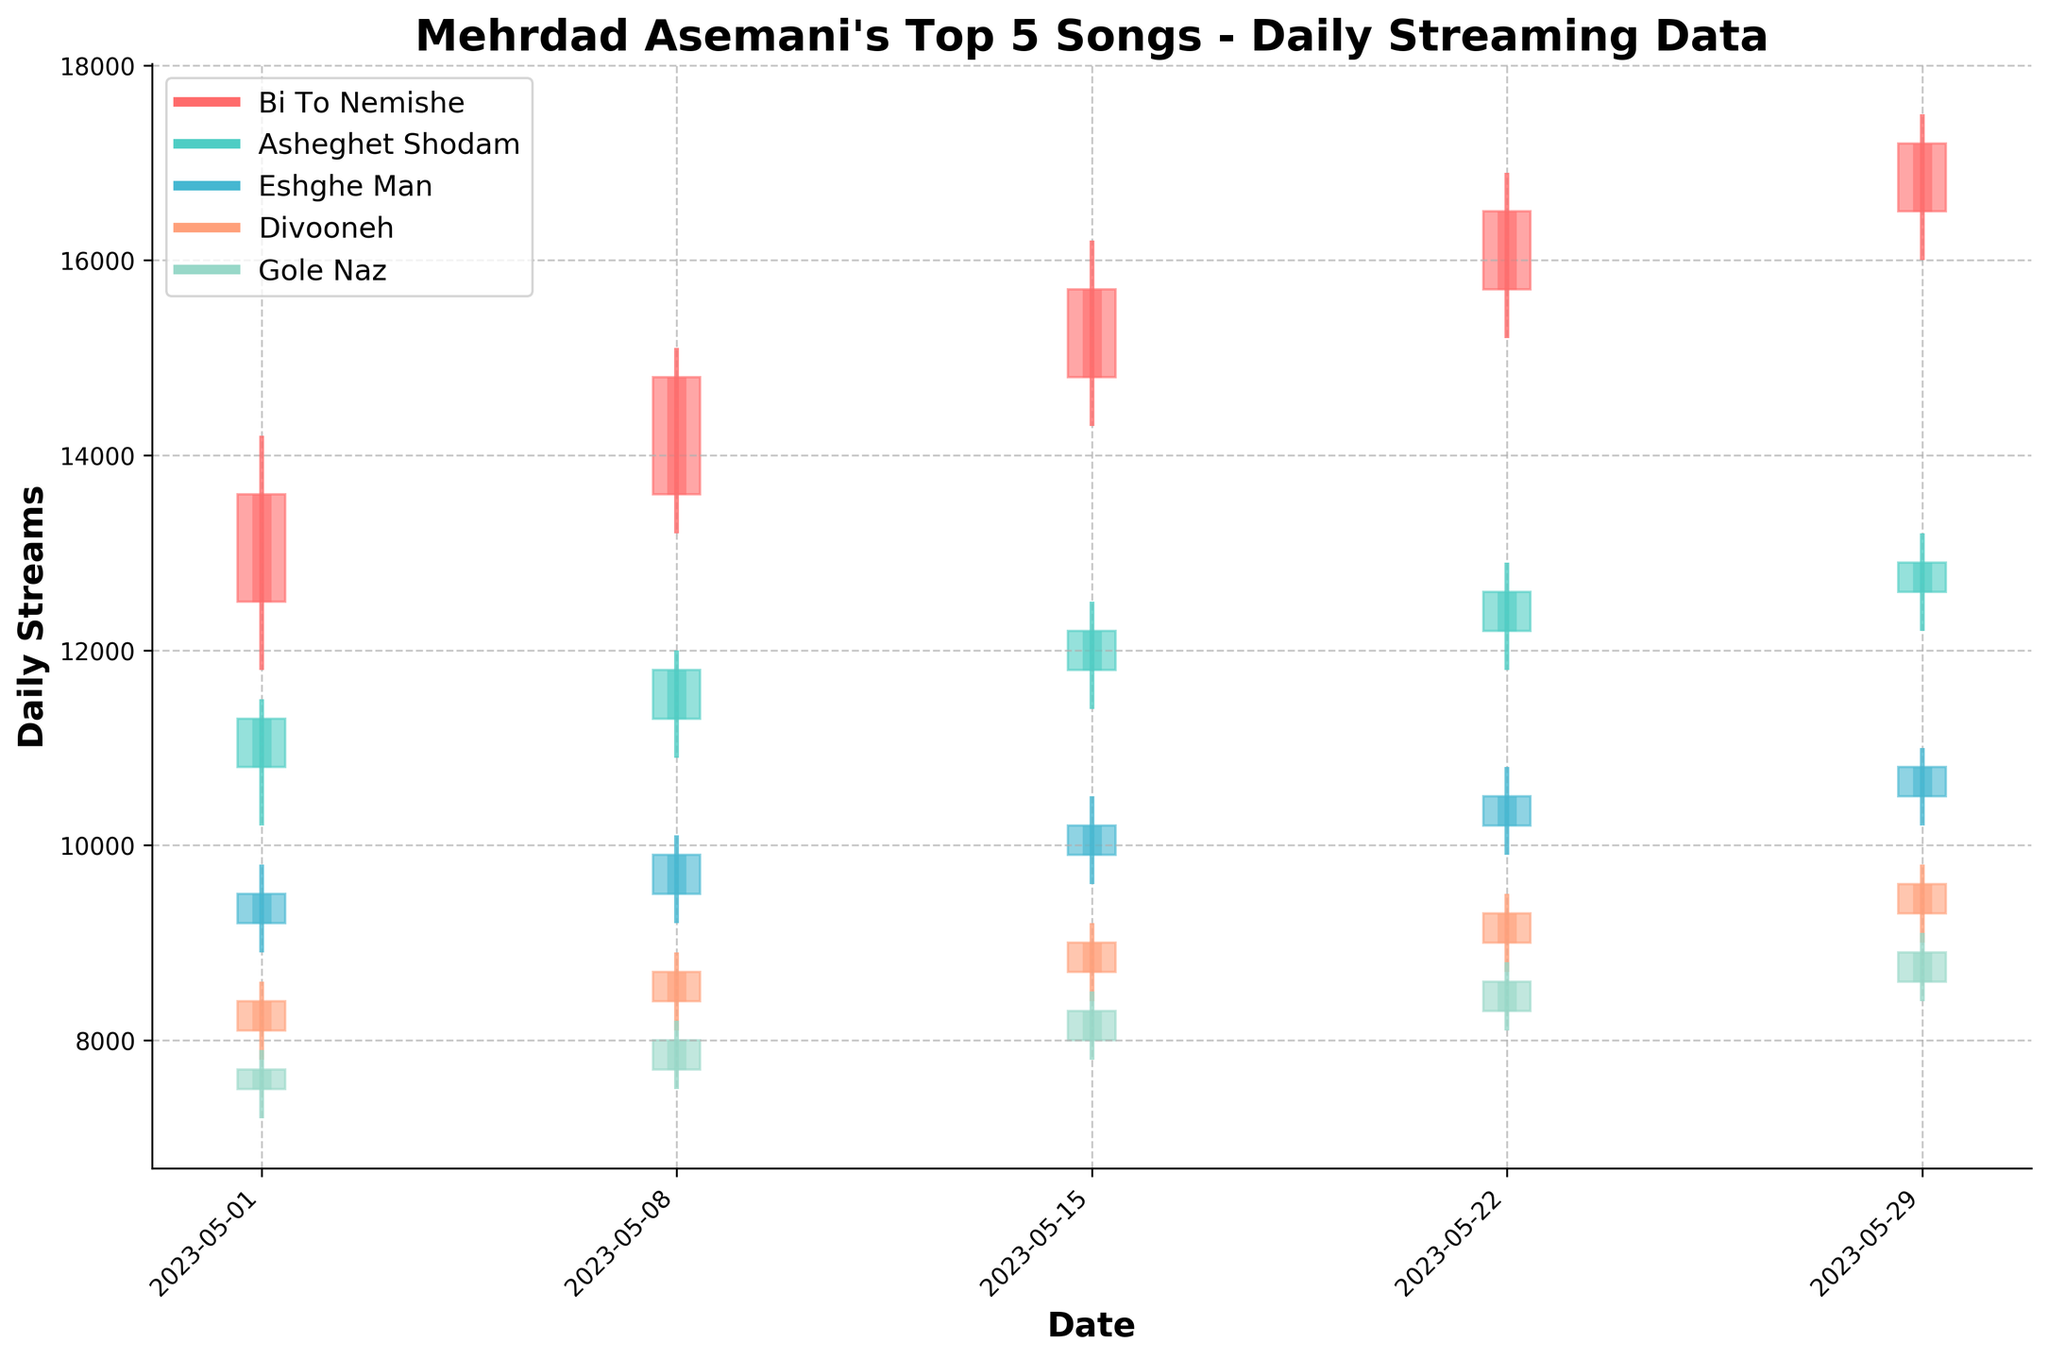What's the title of the chart? The title is usually found at the top of the chart and summarizes the main idea of the visual representation. Here, it states "Mehrdad Asemani's Top 5 Songs - Daily Streaming Data".
Answer: Mehrdad Asemani's Top 5 Songs - Daily Streaming Data What are the date ranges covered in the chart? The dates are usually presented along the x-axis. In this chart, the dates range from 2023-05-01 to 2023-05-29.
Answer: 2023-05-01 to 2023-05-29 Which color represents the song "Divooneh"? Different colors are used to distinguish the songs. By checking the legend, we see that "Divooneh" is represented in a blue shade.
Answer: Blue Which song had the highest closing value on May 29, 2023? To answer this, we locate the May 29, 2023 on the x-axis and compare each song’s closing values. "Bi To Nemishe" had the highest closing value at 17200 streams.
Answer: Bi To Nemishe On which date did the song "Eshghe Man" have the lowest closing value, and what was it? Looking at "Eshghe Man" data points along the x-axis, we find that the closing value was lowest on May 01, 2023, at 9500 streams.
Answer: May 01, 2023, at 9500 streams How did the streaming numbers for "Gole Naz" change from May 01 to May 08, 2023? Compare the opening and closing values for these dates: May 01 (Open: 7500, Close: 7700) and May 08 (Open: 7700, Close: 8000). It shows an increase in both opening and closing values.
Answer: Increased What was the overall trend for the song "Asheghet Shodam" over the month? Observing "Asheghet Shodam" across the x-axis, we notice a consistent increase in both opening and closing values from May 01 (Open: 10800, Close: 11300) to May 29 (Open: 12600, Close: 12900).
Answer: Upward Which song shows the most volatility and how can you tell? Volatility can be assessed by comparing the difference between the high and low values. "Bi To Nemishe" shows the highest range, especially on May 15 to May 29 where differences are most significant.
Answer: Bi To Nemishe How did "Divooneh" perform on May 15 compared to May 08 in terms of closing values? To compare: May 08 (Close: 8700), and May 15 (Close: 9000). "Divooneh" experienced an increase.
Answer: Increased What's the combined closing value of all songs on May 22, 2023? Sum up the closing values for all five songs on this date (16500 + 12600 + 10500 + 9300 + 8600): 16500 + 12600 + 10500 + 9300 + 8600 = 57500.
Answer: 57500 